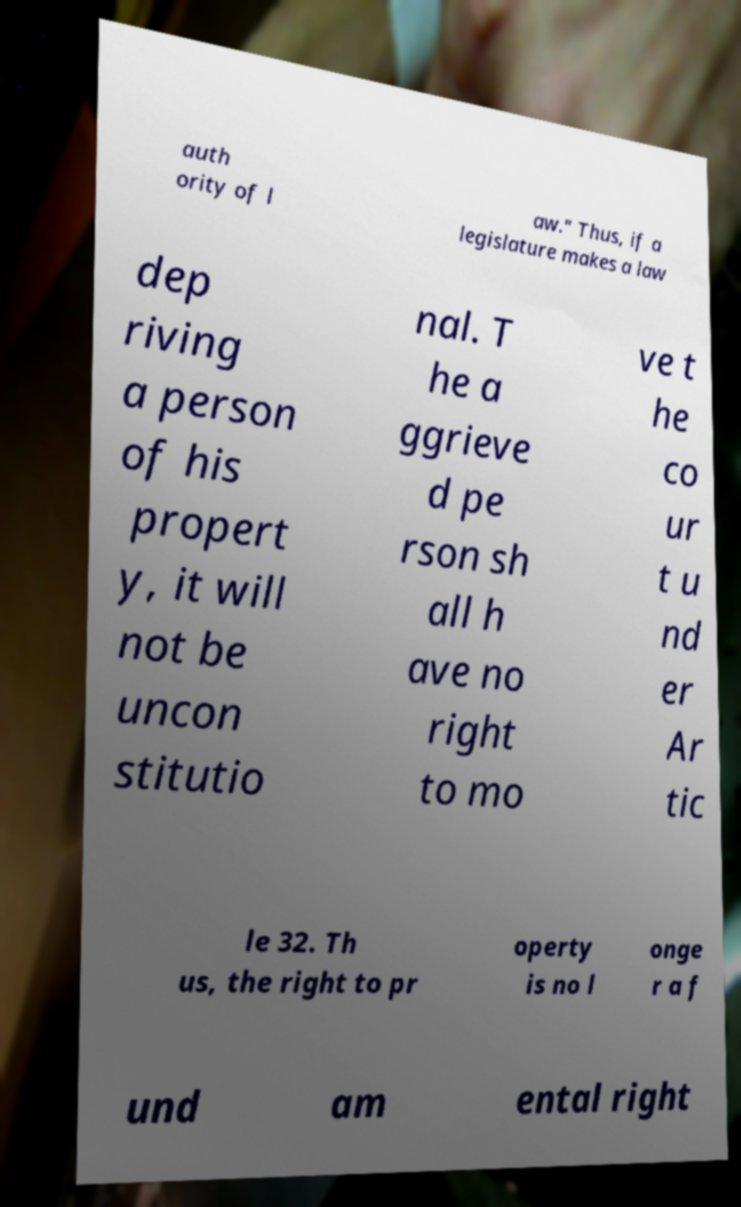Can you accurately transcribe the text from the provided image for me? auth ority of l aw." Thus, if a legislature makes a law dep riving a person of his propert y, it will not be uncon stitutio nal. T he a ggrieve d pe rson sh all h ave no right to mo ve t he co ur t u nd er Ar tic le 32. Th us, the right to pr operty is no l onge r a f und am ental right 